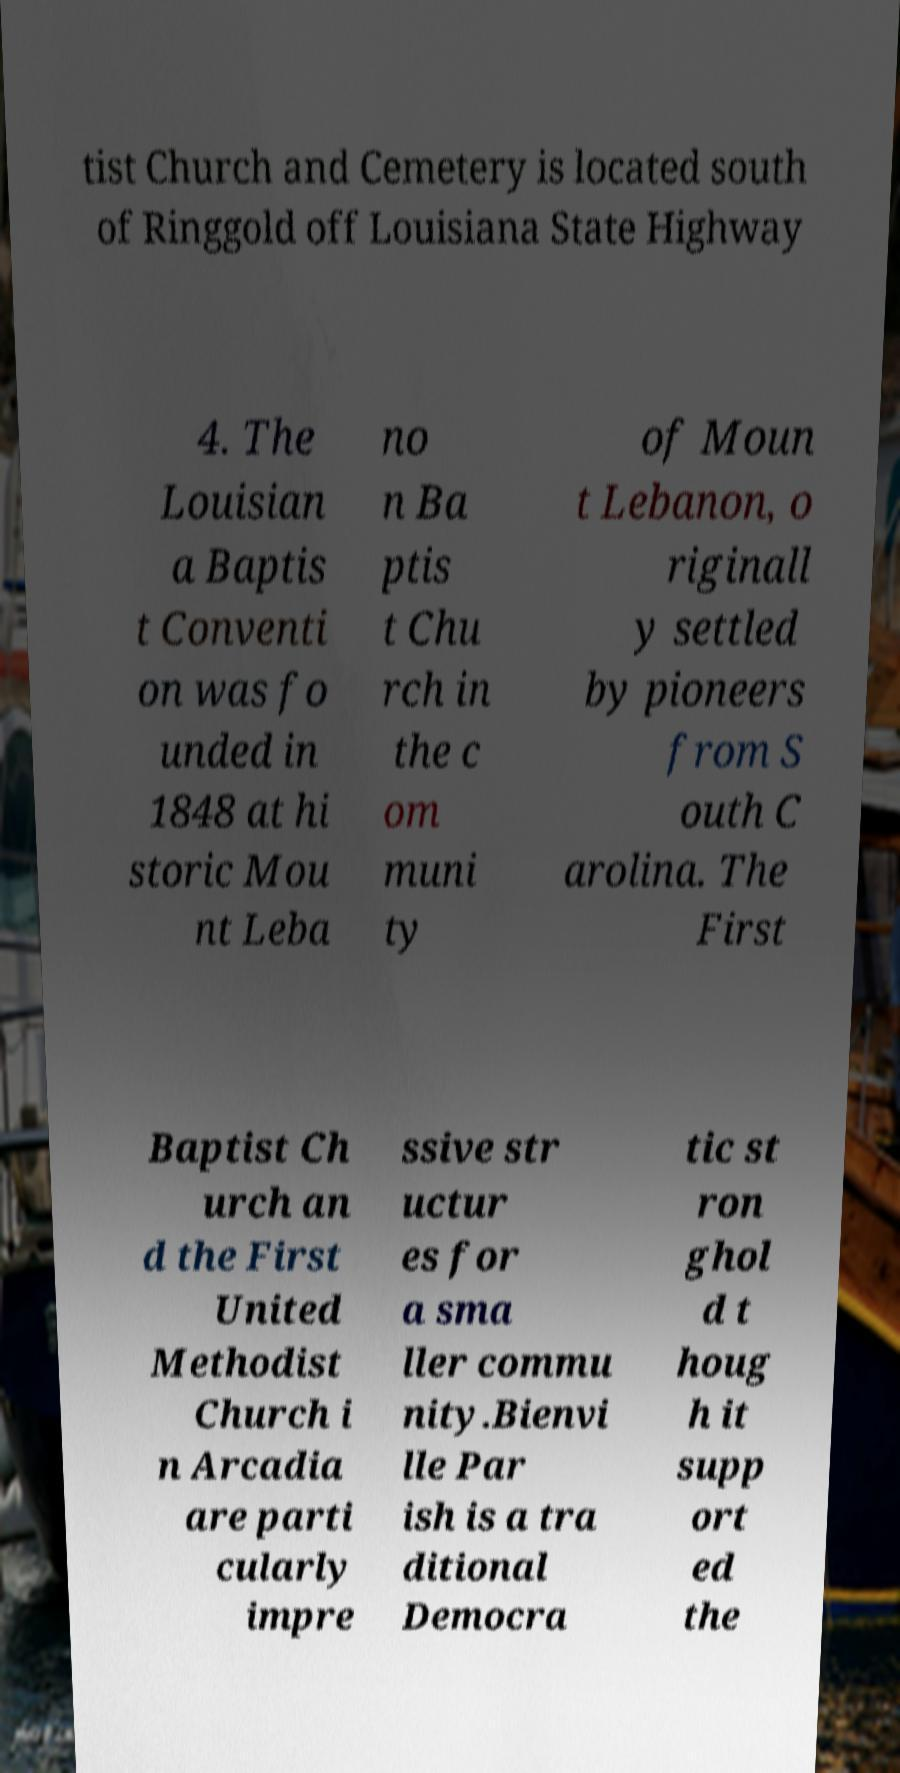I need the written content from this picture converted into text. Can you do that? tist Church and Cemetery is located south of Ringgold off Louisiana State Highway 4. The Louisian a Baptis t Conventi on was fo unded in 1848 at hi storic Mou nt Leba no n Ba ptis t Chu rch in the c om muni ty of Moun t Lebanon, o riginall y settled by pioneers from S outh C arolina. The First Baptist Ch urch an d the First United Methodist Church i n Arcadia are parti cularly impre ssive str uctur es for a sma ller commu nity.Bienvi lle Par ish is a tra ditional Democra tic st ron ghol d t houg h it supp ort ed the 